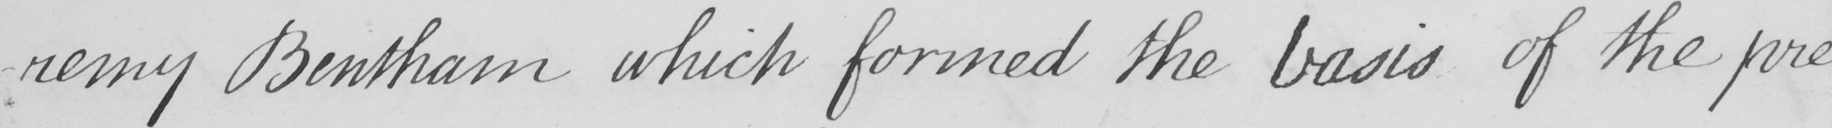Can you tell me what this handwritten text says? remy Bentham which formed the basis of the pre 